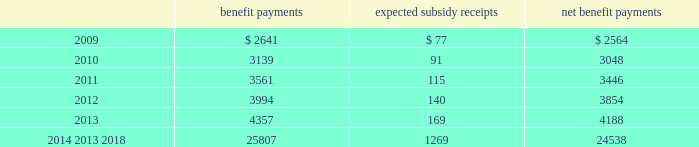Mastercard incorporated notes to consolidated financial statements 2014 ( continued ) ( in thousands , except percent and per share data ) the company does not make any contributions to its postretirement plan other than funding benefits payments .
The table summarizes expected net benefit payments from the company 2019s general assets through 2018 : benefit payments expected subsidy receipts benefit payments .
The company provides limited postemployment benefits to eligible former u.s .
Employees , primarily severance under a formal severance plan ( the 201cseverance plan 201d ) .
The company accounts for severance expense in accordance with sfas no .
112 , 201cemployers 2019 accounting for postemployment benefits 201d by accruing the expected cost of the severance benefits expected to be provided to former employees after employment over their relevant service periods .
The company updates the assumptions in determining the severance accrual by evaluating the actual severance activity and long-term trends underlying the assumptions .
As a result of updating the assumptions , the company recorded severance expense ( benefit ) related to the severance plan of $ 2643 , $ ( 3418 ) and $ 8400 , respectively , during the years 2008 , 2007 and 2006 .
The company has an accrued liability related to the severance plan and other severance obligations in the amount of $ 63863 and $ 56172 at december 31 , 2008 and 2007 , respectively .
Note 13 .
Debt on april 28 , 2008 , the company extended its committed unsecured revolving credit facility , dated as of april 28 , 2006 ( the 201ccredit facility 201d ) , for an additional year .
The new expiration date of the credit facility is april 26 , 2011 .
The available funding under the credit facility will remain at $ 2500000 through april 27 , 2010 and then decrease to $ 2000000 during the final year of the credit facility agreement .
Other terms and conditions in the credit facility remain unchanged .
The company 2019s option to request that each lender under the credit facility extend its commitment was provided pursuant to the original terms of the credit facility agreement .
Borrowings under the facility are available to provide liquidity in the event of one or more settlement failures by mastercard international customers and , subject to a limit of $ 500000 , for general corporate purposes .
A facility fee of 8 basis points on the total commitment , or approximately $ 2030 , is paid annually .
Interest on borrowings under the credit facility would be charged at the london interbank offered rate ( libor ) plus an applicable margin of 37 basis points or an alternative base rate , and a utilization fee of 10 basis points would be charged if outstanding borrowings under the facility exceed 50% ( 50 % ) of commitments .
The facility fee and borrowing cost are contingent upon the company 2019s credit rating .
The company also agreed to pay upfront fees of $ 1250 and administrative fees of $ 325 for the credit facility which are being amortized straight- line over three years .
Facility and other fees associated with the credit facility or prior facilities totaled $ 2353 , $ 2477 and $ 2717 for each of the years ended december 31 , 2008 , 2007 and 2006 , respectively .
Mastercard was in compliance with the covenants of the credit facility and had no borrowings under the credit facility at december 31 , 2008 or december 31 , 2007 .
The majority of credit facility lenders are customers or affiliates of customers of mastercard international .
In june 1998 , mastercard international issued ten-year unsecured , subordinated notes ( the 201cnotes 201d ) paying a fixed interest rate of 6.67% ( 6.67 % ) per annum .
Mastercard repaid the entire principal amount of $ 80000 on june 30 .
Considering the years 2009 and 2010 , what is the difference between the growth of the benefit payments and the expected subsidy receipts? 
Rationale: it is the variation between each percentual growth .
Computations: (((3139 / 2641) - 1) - ((91 / 77) - 1))
Answer: 0.00675. 